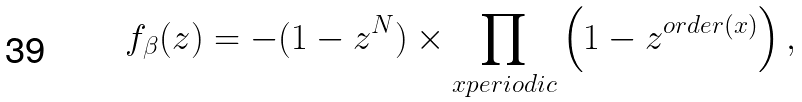<formula> <loc_0><loc_0><loc_500><loc_500>f _ { \beta } ( z ) = - ( 1 - z ^ { N } ) \times \prod _ { x { p e r i o d i c } } \left ( 1 - z ^ { { o r d e r } ( x ) } \right ) ,</formula> 